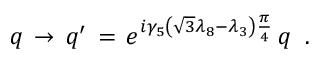Convert formula to latex. <formula><loc_0><loc_0><loc_500><loc_500>q \, \rightarrow \, q ^ { \prime } \, = \, e ^ { i \gamma _ { 5 } \left ( \sqrt { 3 } \lambda _ { 8 } - \lambda _ { 3 } \right ) \frac { \pi } { 4 } } \, q \, .</formula> 